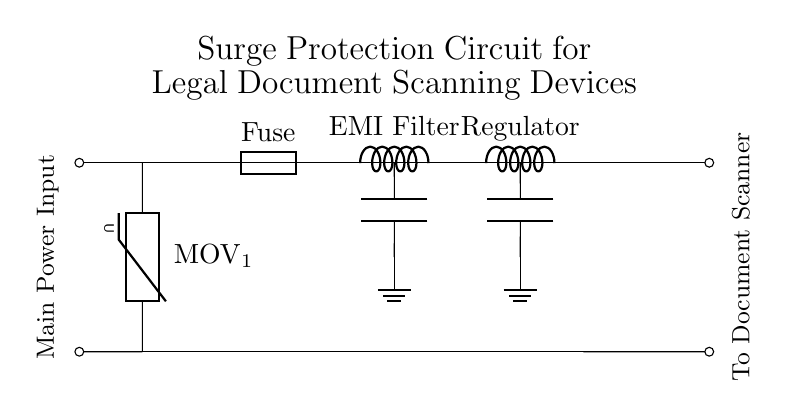What is the function of the MOV in this circuit? The MOV, or Metal Oxide Varistor, serves to absorb voltage spikes and transients, providing protection for downstream components by clamping high transient voltages.
Answer: Absorb voltage spikes What component provides EMI filtering? The inductor labeled as EMI Filter is used to reduce electromagnetic interference from the power line, allowing clean power to flow to the document scanner.
Answer: Inductor How many capacitors are present in the circuit? There are two capacitors in the circuit, one located after the EMI filter and one after the voltage regulator, both serving important filtering purposes.
Answer: Two What is the function of the fuse in this circuit? The fuse protects the circuit from overcurrent, preventing damage to components by breaking the circuit if the current exceeds a predetermined level.
Answer: Protect from overcurrent What does the circuit output connect to? The output marked as "To Document Scanner" connects the power and signal needed by the scanning device to operate effectively and avoid damage from power irregularities.
Answer: Document Scanner 